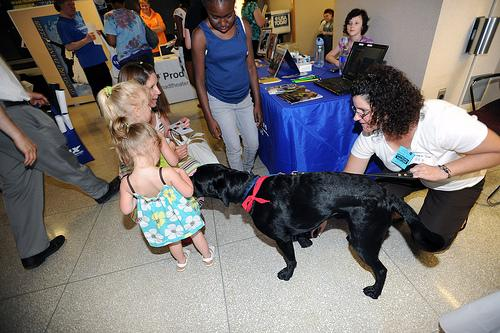Describe an interesting detail about an object on the table. A water bottle with a blue top is placed on the table. What is a notable accessory on the woman next to the dog, and describe her hair. The woman is wearing a blue tag on her shirt and has curly black hair. Describe the tablecloth and mention an object on the table. The table has a royal blue tablecloth, and there is a laptop on top of it. Mention the outfit of the little girl and its specific design. The little girl is wearing a flower dress with yellow and white flowers on it. What kind of clothes are the man and the woman next to the dog wearing? The man is wearing grey suit pants, while the woman next to the dog is wearing black pants. Choose a person in the image, describe their clothes and their activity. A woman at a registration desk is wearing a white shirt and kneeling down with two small toddlers. What is the woman wearing on her eyes and what is she holding? The woman is wearing eyeglasses and holding a black dog with a red scarf around its neck. Talk about the footwear the man and the little girl are wearing. The man is wearing black dress shoes, and the little girl is wearing white sandals. Mention the type and color of the dog and what it seems to be doing, along with a detail about it. A black Labrador Retriever is sniffing children and wearing a red bandana around its neck. Talk about the floor in the image and any distinctive details. The floor has white speckled tile and is made up of tan and grey floor tiles. 